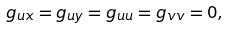Convert formula to latex. <formula><loc_0><loc_0><loc_500><loc_500>g _ { u x } = g _ { u y } = g _ { u u } = g _ { v v } = 0 ,</formula> 